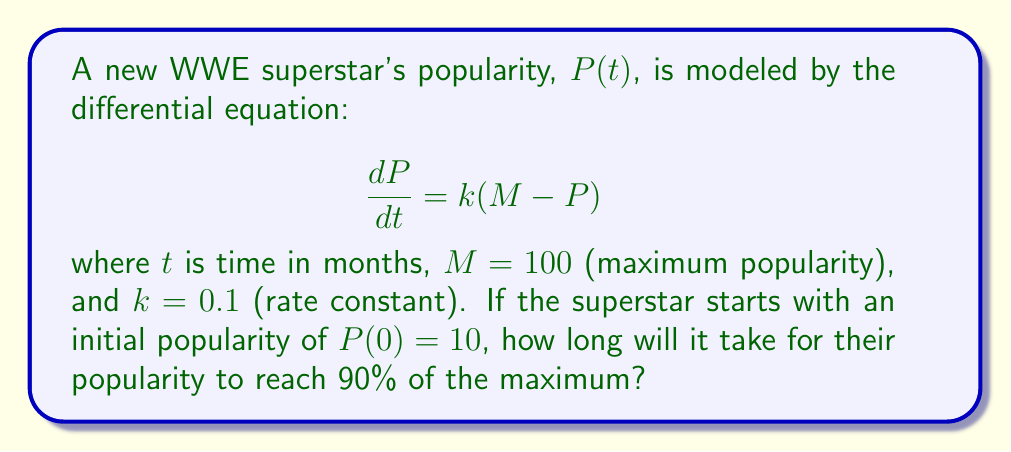Show me your answer to this math problem. To solve this problem, we need to follow these steps:

1) First, we need to solve the given differential equation:

   $$\frac{dP}{dt} = k(M - P)$$

2) This is a separable equation. Rearranging it:

   $$\frac{dP}{M - P} = k dt$$

3) Integrating both sides:

   $$\int \frac{dP}{M - P} = \int k dt$$

   $$-\ln|M - P| = kt + C$$

4) Using the initial condition $P(0) = 10$:

   $$-\ln|100 - 10| = 0 + C$$
   $$C = -\ln(90)$$

5) Therefore, the general solution is:

   $$-\ln|M - P| = kt - \ln(90)$$
   $$\ln|M - P| = \ln(90) - kt$$
   $$|M - P| = 90e^{-kt}$$
   $$P = M - 90e^{-kt}$$

6) We want to find $t$ when $P = 0.9M = 90$:

   $$90 = 100 - 90e^{-0.1t}$$
   $$10 = 90e^{-0.1t}$$
   $$\frac{1}{9} = e^{-0.1t}$$

7) Taking natural log of both sides:

   $$\ln(\frac{1}{9}) = -0.1t$$
   $$t = \frac{-\ln(\frac{1}{9})}{0.1} = \frac{\ln(9)}{0.1} \approx 22.0$$

Therefore, it will take approximately 22.0 months for the superstar to reach 90% popularity.
Answer: Approximately 22.0 months 